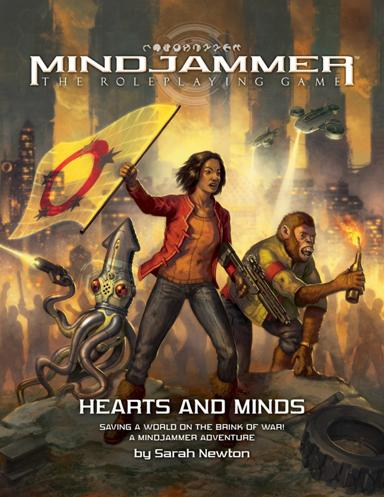What is Mindjammer about? 'Mindjammer' is a science fiction role-playing game set in a future of space exploration and cultural clashes. Players engage in missions that challenge their strategic thinking and moral choices, as they navigate a universe on the cusp of transformation and conflict. The game emphasizes the importance of collective intelligence and mind-sharing technology, inviting a layered, strategic gameplay experience. 